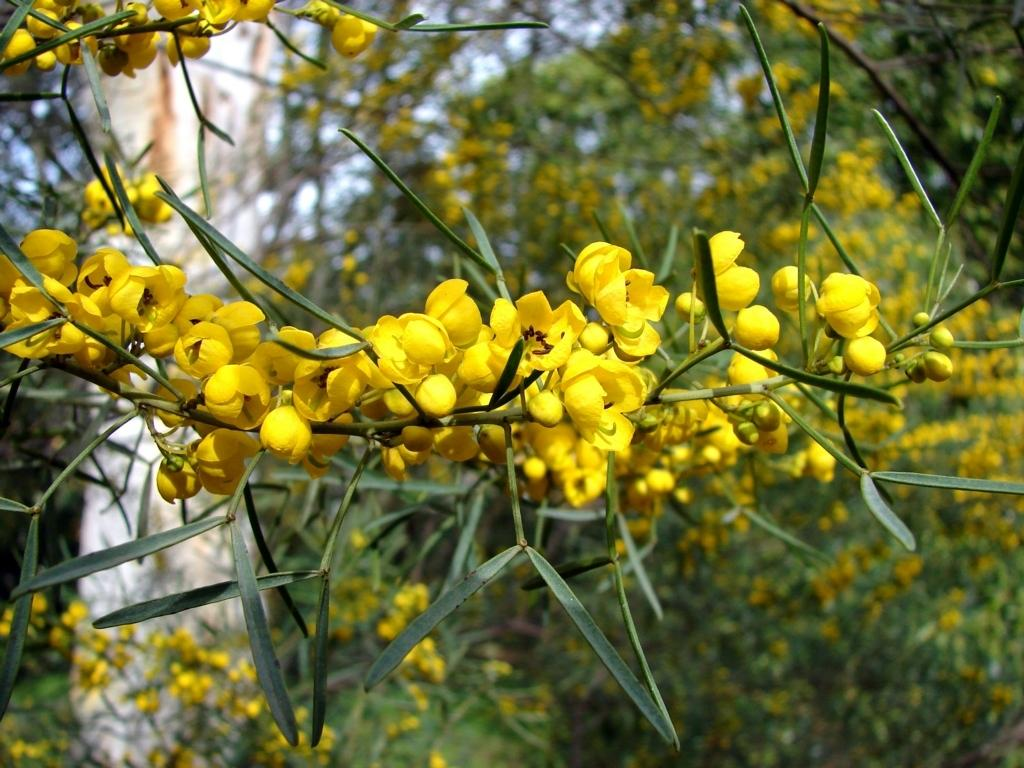What type of flowers can be seen on the tree branch in the image? There are yellow flowers on the tree branch in the image. What color are the leaves at the bottom of the tree branch? The leaves at the bottom of the tree branch are green. What can be seen in the background of the image? There are many trees visible in the background of the image. What is visible at the top of the image? The sky is visible at the top of the image. How many sheep are present in the image? There are no sheep present in the image; it features a tree branch with yellow flowers and green leaves. What type of wool can be seen on the tree branch in the image? There is no wool present on the tree branch in the image; it features yellow flowers and green leaves. 